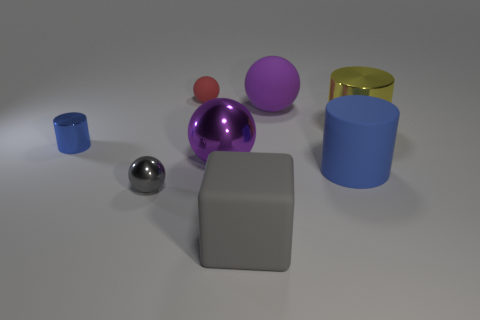How would you describe the composition of this scene? The composition of the scene is balanced, with objects of varying colors, sizes, and shapes evenly distributed. It provides a visual contrast and keeps the viewer's eye moving around the image to inspect each element. 